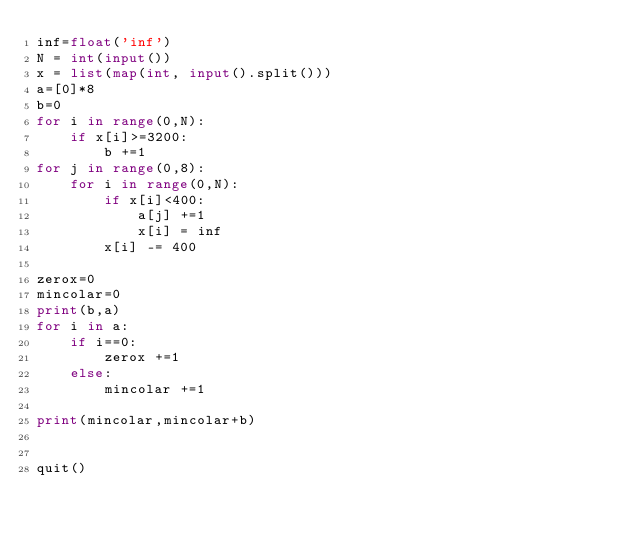Convert code to text. <code><loc_0><loc_0><loc_500><loc_500><_Python_>inf=float('inf')
N = int(input())
x = list(map(int, input().split()))
a=[0]*8
b=0
for i in range(0,N):
    if x[i]>=3200:
        b +=1
for j in range(0,8):
    for i in range(0,N):
        if x[i]<400:
            a[j] +=1
            x[i] = inf
        x[i] -= 400

zerox=0
mincolar=0
print(b,a)
for i in a:
    if i==0:
        zerox +=1  
    else:
        mincolar +=1

print(mincolar,mincolar+b)


quit()
</code> 